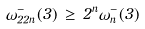Convert formula to latex. <formula><loc_0><loc_0><loc_500><loc_500>\omega _ { 2 2 n } ^ { - } ( 3 ) \, \geq \, 2 ^ { n } \omega _ { n } ^ { - } ( 3 )</formula> 